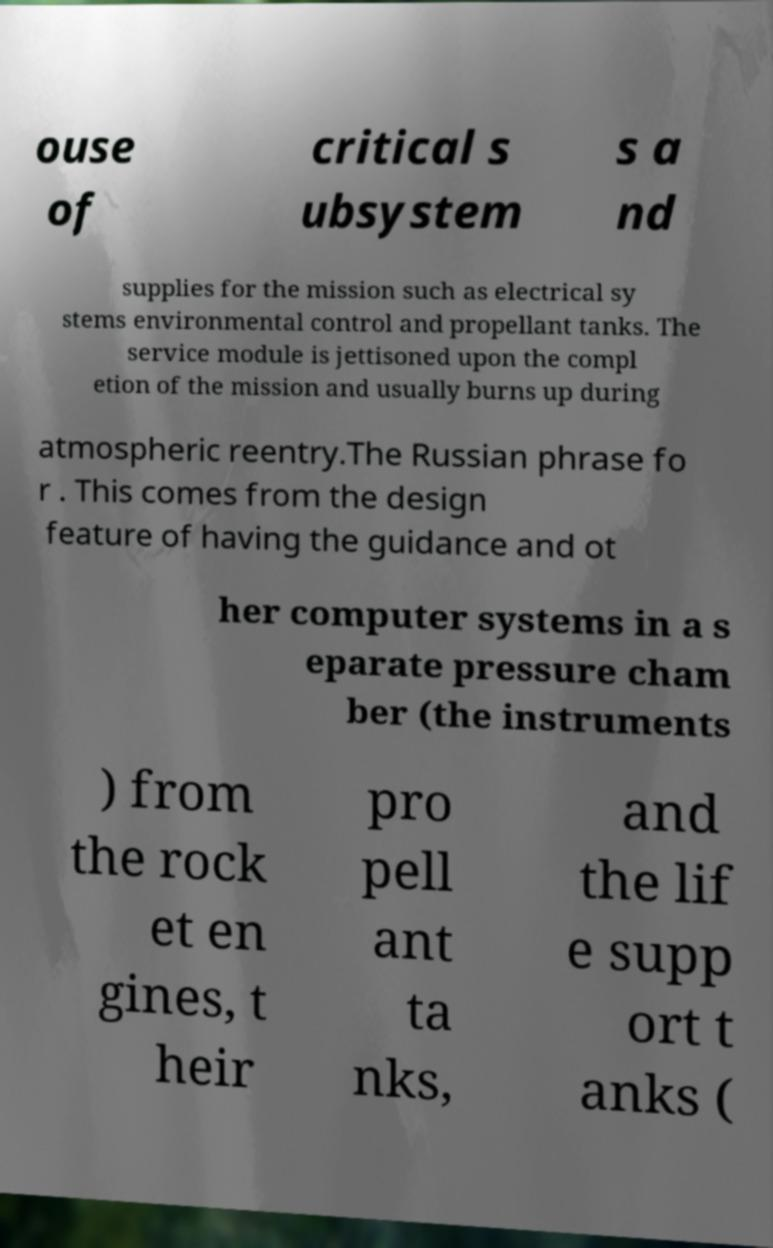There's text embedded in this image that I need extracted. Can you transcribe it verbatim? ouse of critical s ubsystem s a nd supplies for the mission such as electrical sy stems environmental control and propellant tanks. The service module is jettisoned upon the compl etion of the mission and usually burns up during atmospheric reentry.The Russian phrase fo r . This comes from the design feature of having the guidance and ot her computer systems in a s eparate pressure cham ber (the instruments ) from the rock et en gines, t heir pro pell ant ta nks, and the lif e supp ort t anks ( 